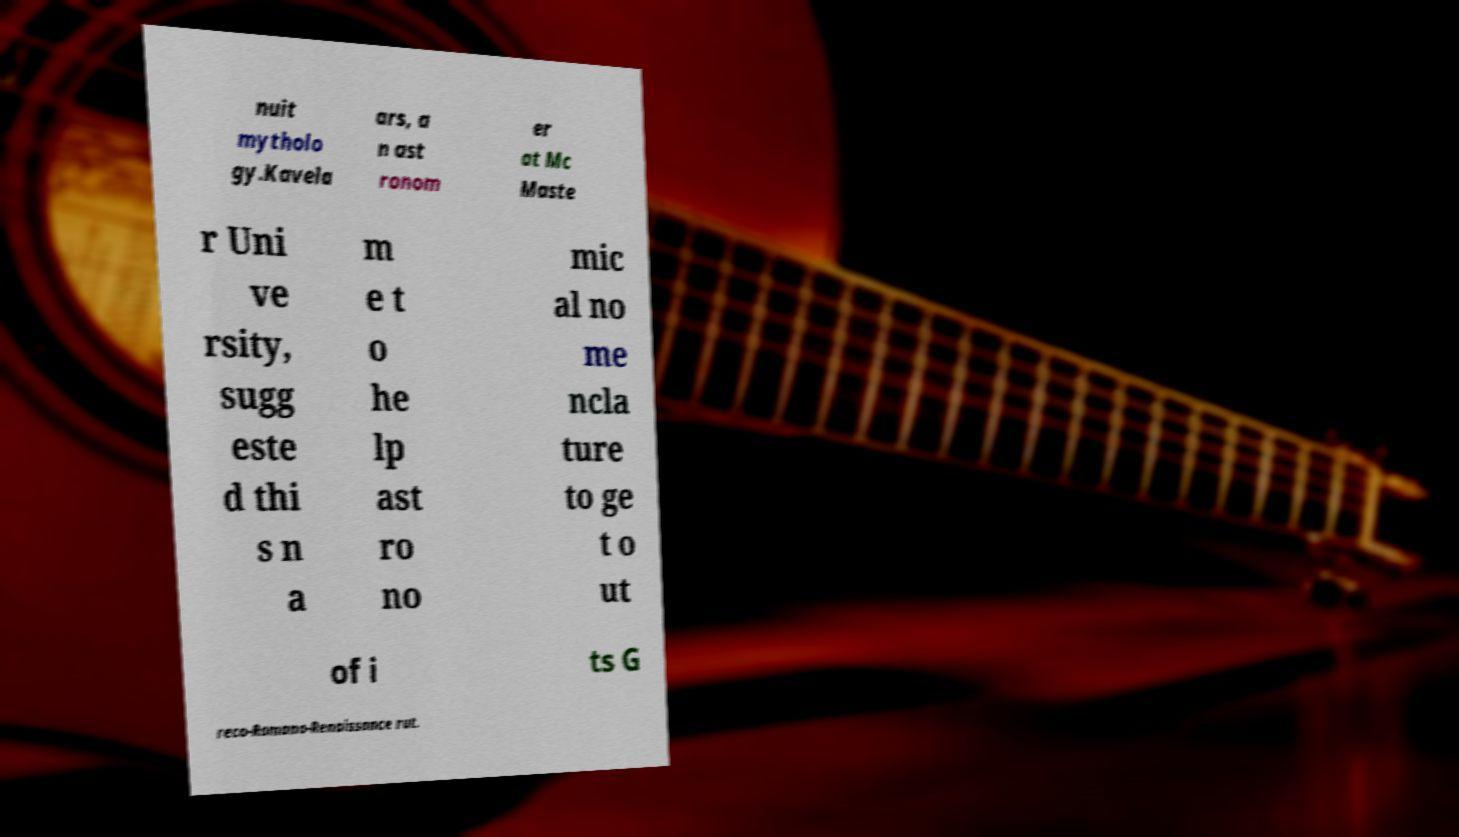I need the written content from this picture converted into text. Can you do that? nuit mytholo gy.Kavela ars, a n ast ronom er at Mc Maste r Uni ve rsity, sugg este d thi s n a m e t o he lp ast ro no mic al no me ncla ture to ge t o ut of i ts G reco-Romano-Renaissance rut. 